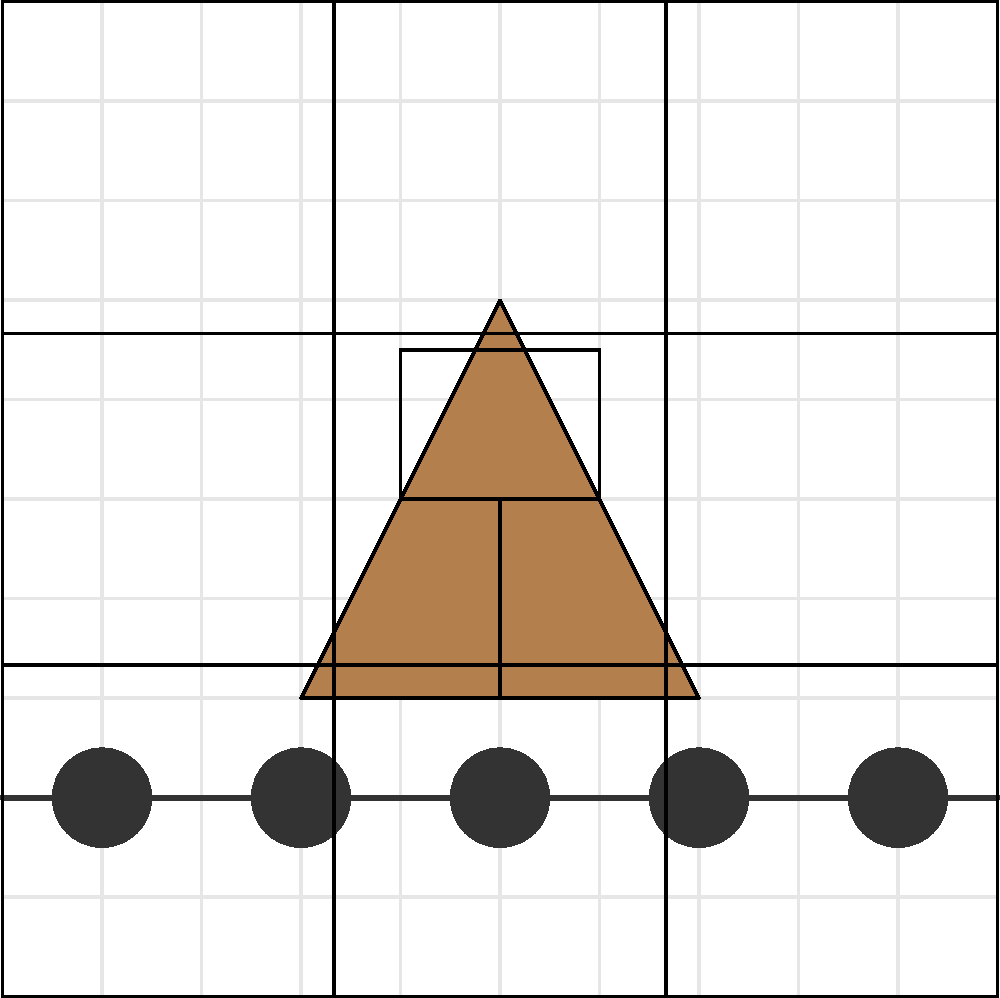Analyze the composition of this protest photograph. Which rule of composition is most prominently utilized to create visual impact and draw attention to the main subject? To analyze the composition of this protest photograph, let's follow these steps:

1. Identify the main elements:
   - A protestor in the center
   - A police line at the bottom
   - A protest sign held by the protestor

2. Observe the placement of elements:
   - The protestor is positioned in the center of the frame
   - The police line creates a strong horizontal at the bottom third
   - The protest sign is held high, drawing the eye upward

3. Recognize compositional techniques:
   - Rule of Thirds: The image is divided into a 3x3 grid
   - The police line aligns with the bottom horizontal third line
   - The protestor's body occupies the central vertical third

4. Analyze the visual impact:
   - The protestor stands out against the background
   - The contrast between the protestor and police line creates tension
   - The central placement of the protestor emphasizes their importance

5. Conclude the primary compositional rule:
   - While the Rule of Thirds is present, the most prominent technique is the use of central composition
   - The protestor is deliberately placed in the center to command attention and convey power

The central composition in this photograph creates a strong visual impact by placing the protestor as the focal point, emphasizing their significance in the scene and the power of their stance against the backdrop of authority.
Answer: Central composition 